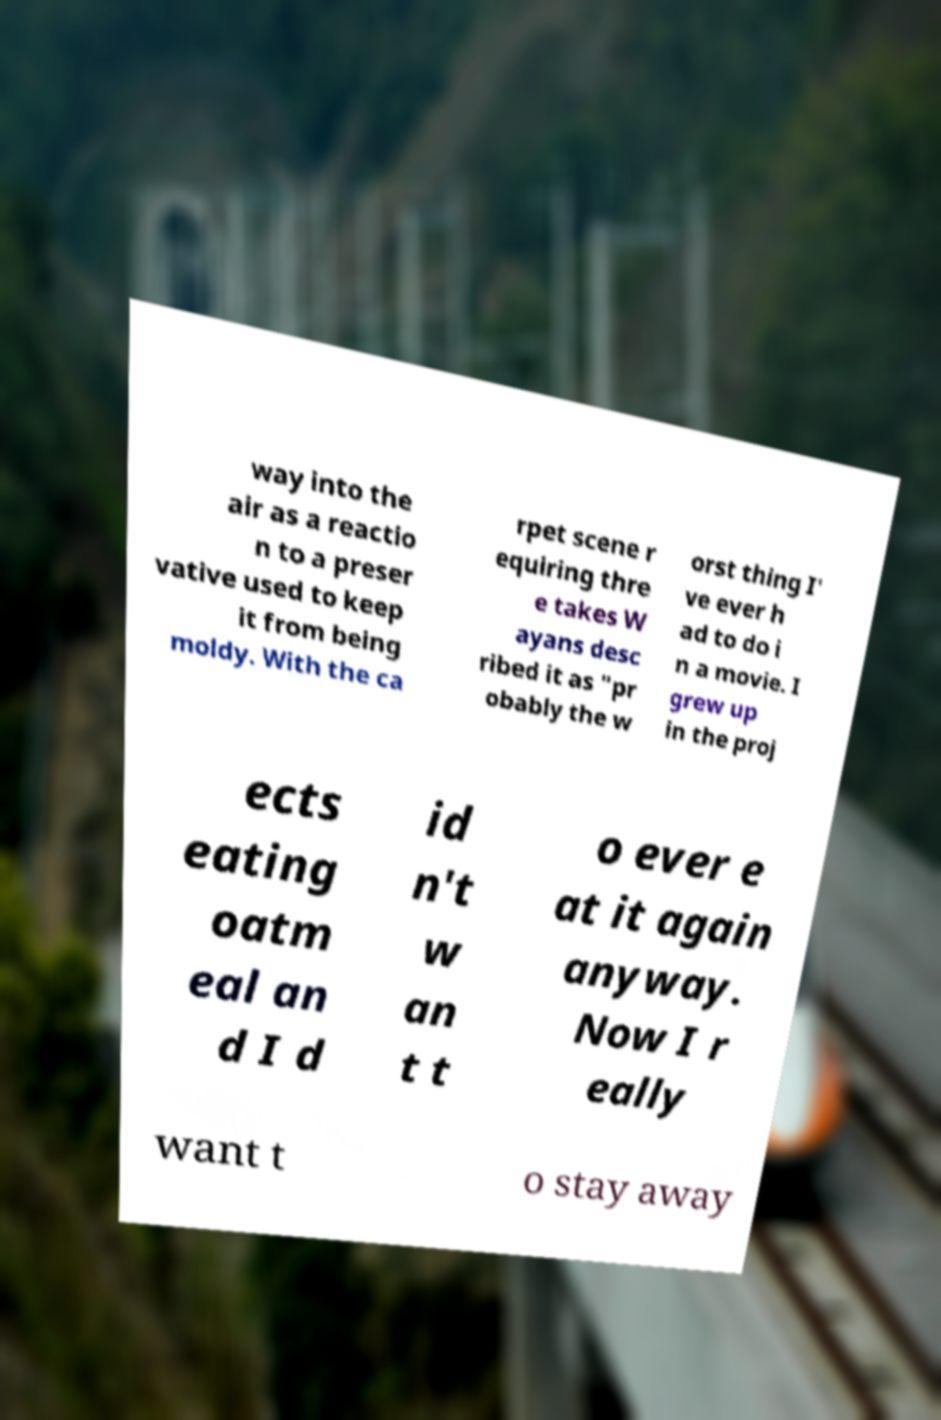What messages or text are displayed in this image? I need them in a readable, typed format. way into the air as a reactio n to a preser vative used to keep it from being moldy. With the ca rpet scene r equiring thre e takes W ayans desc ribed it as "pr obably the w orst thing I' ve ever h ad to do i n a movie. I grew up in the proj ects eating oatm eal an d I d id n't w an t t o ever e at it again anyway. Now I r eally want t o stay away 